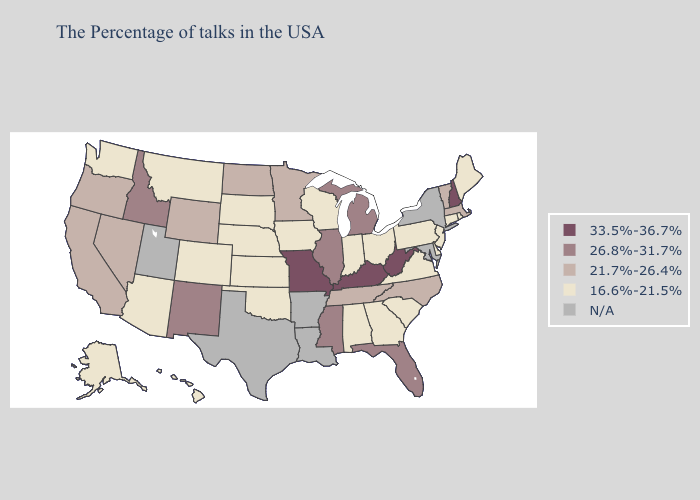Name the states that have a value in the range 33.5%-36.7%?
Be succinct. New Hampshire, West Virginia, Kentucky, Missouri. What is the lowest value in states that border Georgia?
Write a very short answer. 16.6%-21.5%. What is the lowest value in states that border North Dakota?
Give a very brief answer. 16.6%-21.5%. What is the lowest value in the USA?
Write a very short answer. 16.6%-21.5%. What is the highest value in the Northeast ?
Give a very brief answer. 33.5%-36.7%. What is the highest value in the Northeast ?
Concise answer only. 33.5%-36.7%. Name the states that have a value in the range 26.8%-31.7%?
Keep it brief. Florida, Michigan, Illinois, Mississippi, New Mexico, Idaho. Does West Virginia have the highest value in the USA?
Answer briefly. Yes. Name the states that have a value in the range 21.7%-26.4%?
Give a very brief answer. Massachusetts, Vermont, North Carolina, Tennessee, Minnesota, North Dakota, Wyoming, Nevada, California, Oregon. What is the value of Iowa?
Answer briefly. 16.6%-21.5%. Name the states that have a value in the range N/A?
Write a very short answer. New York, Maryland, Louisiana, Arkansas, Texas, Utah. Is the legend a continuous bar?
Be succinct. No. Name the states that have a value in the range 21.7%-26.4%?
Be succinct. Massachusetts, Vermont, North Carolina, Tennessee, Minnesota, North Dakota, Wyoming, Nevada, California, Oregon. 